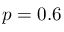Convert formula to latex. <formula><loc_0><loc_0><loc_500><loc_500>p = 0 . 6</formula> 